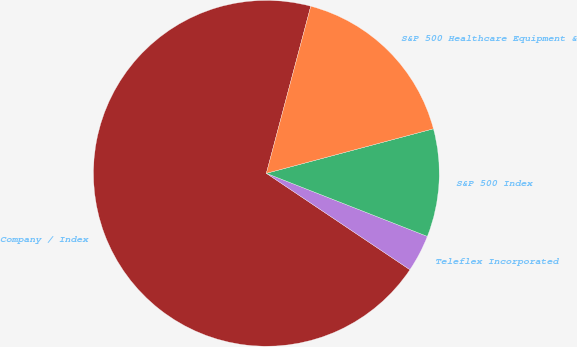<chart> <loc_0><loc_0><loc_500><loc_500><pie_chart><fcel>Company / Index<fcel>Teleflex Incorporated<fcel>S&P 500 Index<fcel>S&P 500 Healthcare Equipment &<nl><fcel>69.73%<fcel>3.47%<fcel>10.09%<fcel>16.72%<nl></chart> 